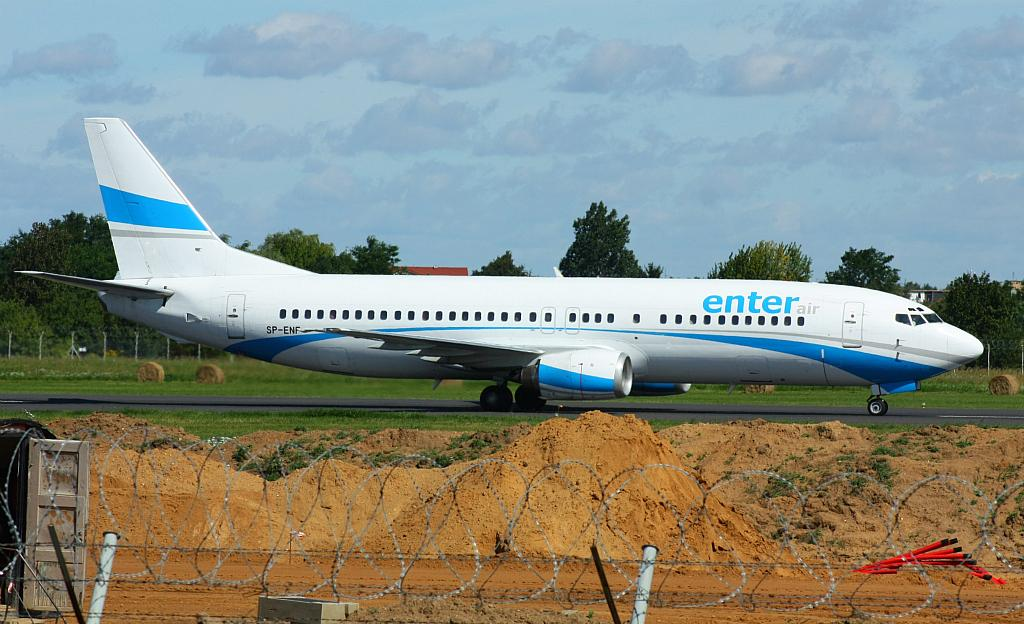<image>
Relay a brief, clear account of the picture shown. Blue and white enter air airplane SP-ENF label 